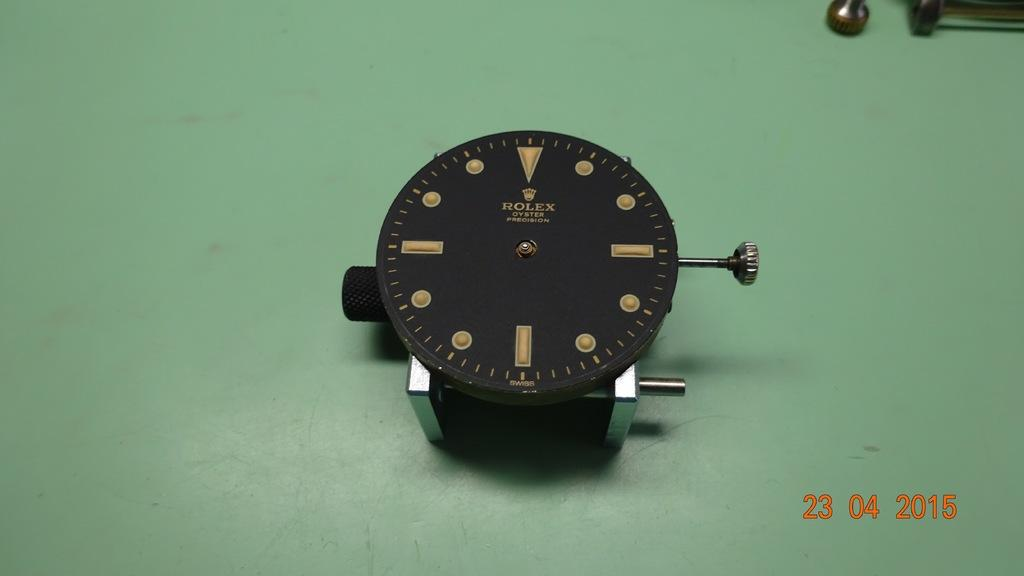What is the main subject in the image? There is an object in the image. What is the color of the surface on which the object is placed? The object is on a green color surface. Can you describe any additional features of the image? There is a watermark in the image. How does the key help the porter breathe in the image? There is no key or porter present in the image, so this question cannot be answered. 